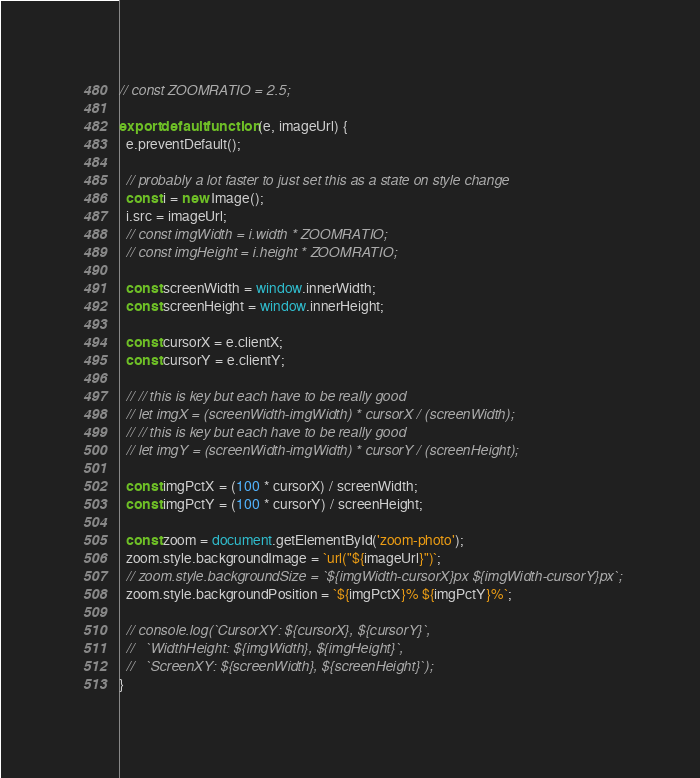<code> <loc_0><loc_0><loc_500><loc_500><_JavaScript_>// const ZOOMRATIO = 2.5;

export default function (e, imageUrl) {
  e.preventDefault();

  // probably a lot faster to just set this as a state on style change
  const i = new Image();
  i.src = imageUrl;
  // const imgWidth = i.width * ZOOMRATIO;
  // const imgHeight = i.height * ZOOMRATIO;

  const screenWidth = window.innerWidth;
  const screenHeight = window.innerHeight;

  const cursorX = e.clientX;
  const cursorY = e.clientY;

  // // this is key but each have to be really good
  // let imgX = (screenWidth-imgWidth) * cursorX / (screenWidth);
  // // this is key but each have to be really good
  // let imgY = (screenWidth-imgWidth) * cursorY / (screenHeight);

  const imgPctX = (100 * cursorX) / screenWidth;
  const imgPctY = (100 * cursorY) / screenHeight;

  const zoom = document.getElementById('zoom-photo');
  zoom.style.backgroundImage = `url("${imageUrl}")`;
  // zoom.style.backgroundSize = `${imgWidth-cursorX}px ${imgWidth-cursorY}px`;
  zoom.style.backgroundPosition = `${imgPctX}% ${imgPctY}%`;

  // console.log(`CursorXY: ${cursorX}, ${cursorY}`,
  //   `WidthHeight: ${imgWidth}, ${imgHeight}`,
  //   `ScreenXY: ${screenWidth}, ${screenHeight}`);
}
</code> 